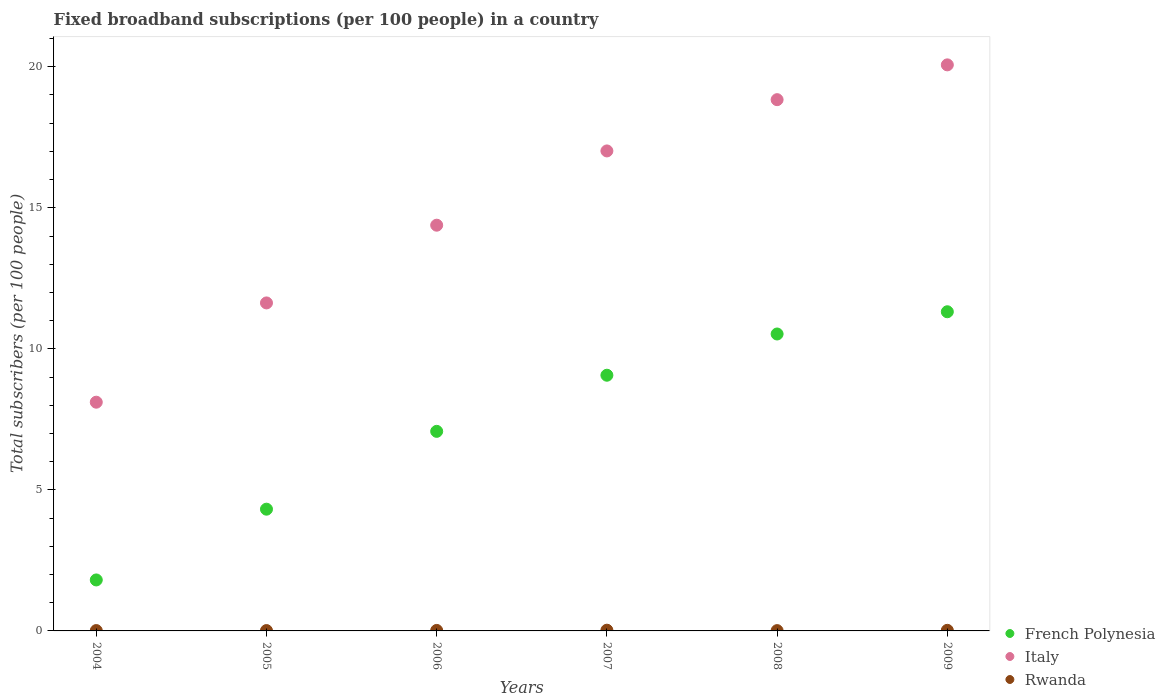How many different coloured dotlines are there?
Your answer should be compact. 3. What is the number of broadband subscriptions in Rwanda in 2008?
Make the answer very short. 0.01. Across all years, what is the maximum number of broadband subscriptions in Rwanda?
Give a very brief answer. 0.03. Across all years, what is the minimum number of broadband subscriptions in Italy?
Offer a very short reply. 8.11. In which year was the number of broadband subscriptions in Rwanda maximum?
Provide a succinct answer. 2007. What is the total number of broadband subscriptions in Rwanda in the graph?
Provide a succinct answer. 0.1. What is the difference between the number of broadband subscriptions in Italy in 2004 and that in 2007?
Your answer should be compact. -8.91. What is the difference between the number of broadband subscriptions in Italy in 2005 and the number of broadband subscriptions in Rwanda in 2009?
Your answer should be very brief. 11.61. What is the average number of broadband subscriptions in French Polynesia per year?
Provide a succinct answer. 7.35. In the year 2004, what is the difference between the number of broadband subscriptions in Rwanda and number of broadband subscriptions in French Polynesia?
Make the answer very short. -1.79. In how many years, is the number of broadband subscriptions in French Polynesia greater than 11?
Provide a short and direct response. 1. What is the ratio of the number of broadband subscriptions in French Polynesia in 2007 to that in 2009?
Offer a very short reply. 0.8. Is the difference between the number of broadband subscriptions in Rwanda in 2007 and 2008 greater than the difference between the number of broadband subscriptions in French Polynesia in 2007 and 2008?
Provide a succinct answer. Yes. What is the difference between the highest and the second highest number of broadband subscriptions in Italy?
Your answer should be very brief. 1.23. What is the difference between the highest and the lowest number of broadband subscriptions in Rwanda?
Make the answer very short. 0.01. In how many years, is the number of broadband subscriptions in French Polynesia greater than the average number of broadband subscriptions in French Polynesia taken over all years?
Ensure brevity in your answer.  3. Is it the case that in every year, the sum of the number of broadband subscriptions in Rwanda and number of broadband subscriptions in French Polynesia  is greater than the number of broadband subscriptions in Italy?
Offer a terse response. No. Does the number of broadband subscriptions in Rwanda monotonically increase over the years?
Give a very brief answer. No. Is the number of broadband subscriptions in French Polynesia strictly less than the number of broadband subscriptions in Italy over the years?
Give a very brief answer. Yes. What is the difference between two consecutive major ticks on the Y-axis?
Give a very brief answer. 5. What is the title of the graph?
Your response must be concise. Fixed broadband subscriptions (per 100 people) in a country. Does "Congo (Democratic)" appear as one of the legend labels in the graph?
Make the answer very short. No. What is the label or title of the Y-axis?
Your response must be concise. Total subscribers (per 100 people). What is the Total subscribers (per 100 people) of French Polynesia in 2004?
Ensure brevity in your answer.  1.81. What is the Total subscribers (per 100 people) of Italy in 2004?
Make the answer very short. 8.11. What is the Total subscribers (per 100 people) in Rwanda in 2004?
Provide a succinct answer. 0.01. What is the Total subscribers (per 100 people) in French Polynesia in 2005?
Make the answer very short. 4.32. What is the Total subscribers (per 100 people) of Italy in 2005?
Offer a very short reply. 11.63. What is the Total subscribers (per 100 people) of Rwanda in 2005?
Keep it short and to the point. 0.01. What is the Total subscribers (per 100 people) of French Polynesia in 2006?
Offer a terse response. 7.07. What is the Total subscribers (per 100 people) of Italy in 2006?
Offer a very short reply. 14.38. What is the Total subscribers (per 100 people) of Rwanda in 2006?
Make the answer very short. 0.02. What is the Total subscribers (per 100 people) of French Polynesia in 2007?
Offer a terse response. 9.06. What is the Total subscribers (per 100 people) of Italy in 2007?
Offer a very short reply. 17.02. What is the Total subscribers (per 100 people) in Rwanda in 2007?
Your answer should be compact. 0.03. What is the Total subscribers (per 100 people) in French Polynesia in 2008?
Offer a very short reply. 10.53. What is the Total subscribers (per 100 people) in Italy in 2008?
Your answer should be very brief. 18.83. What is the Total subscribers (per 100 people) of Rwanda in 2008?
Your response must be concise. 0.01. What is the Total subscribers (per 100 people) of French Polynesia in 2009?
Offer a terse response. 11.31. What is the Total subscribers (per 100 people) in Italy in 2009?
Offer a very short reply. 20.07. What is the Total subscribers (per 100 people) in Rwanda in 2009?
Offer a very short reply. 0.02. Across all years, what is the maximum Total subscribers (per 100 people) in French Polynesia?
Keep it short and to the point. 11.31. Across all years, what is the maximum Total subscribers (per 100 people) of Italy?
Ensure brevity in your answer.  20.07. Across all years, what is the maximum Total subscribers (per 100 people) in Rwanda?
Give a very brief answer. 0.03. Across all years, what is the minimum Total subscribers (per 100 people) of French Polynesia?
Keep it short and to the point. 1.81. Across all years, what is the minimum Total subscribers (per 100 people) of Italy?
Offer a terse response. 8.11. Across all years, what is the minimum Total subscribers (per 100 people) of Rwanda?
Ensure brevity in your answer.  0.01. What is the total Total subscribers (per 100 people) of French Polynesia in the graph?
Provide a succinct answer. 44.1. What is the total Total subscribers (per 100 people) in Italy in the graph?
Offer a terse response. 90.04. What is the total Total subscribers (per 100 people) of Rwanda in the graph?
Give a very brief answer. 0.1. What is the difference between the Total subscribers (per 100 people) in French Polynesia in 2004 and that in 2005?
Keep it short and to the point. -2.51. What is the difference between the Total subscribers (per 100 people) of Italy in 2004 and that in 2005?
Provide a short and direct response. -3.52. What is the difference between the Total subscribers (per 100 people) in Rwanda in 2004 and that in 2005?
Your answer should be very brief. -0. What is the difference between the Total subscribers (per 100 people) of French Polynesia in 2004 and that in 2006?
Your response must be concise. -5.27. What is the difference between the Total subscribers (per 100 people) in Italy in 2004 and that in 2006?
Offer a terse response. -6.28. What is the difference between the Total subscribers (per 100 people) of Rwanda in 2004 and that in 2006?
Offer a terse response. -0.01. What is the difference between the Total subscribers (per 100 people) in French Polynesia in 2004 and that in 2007?
Provide a short and direct response. -7.26. What is the difference between the Total subscribers (per 100 people) in Italy in 2004 and that in 2007?
Your answer should be very brief. -8.91. What is the difference between the Total subscribers (per 100 people) of Rwanda in 2004 and that in 2007?
Keep it short and to the point. -0.01. What is the difference between the Total subscribers (per 100 people) of French Polynesia in 2004 and that in 2008?
Your answer should be compact. -8.72. What is the difference between the Total subscribers (per 100 people) of Italy in 2004 and that in 2008?
Your answer should be compact. -10.72. What is the difference between the Total subscribers (per 100 people) in Rwanda in 2004 and that in 2008?
Offer a very short reply. 0. What is the difference between the Total subscribers (per 100 people) in French Polynesia in 2004 and that in 2009?
Keep it short and to the point. -9.51. What is the difference between the Total subscribers (per 100 people) in Italy in 2004 and that in 2009?
Offer a very short reply. -11.96. What is the difference between the Total subscribers (per 100 people) in Rwanda in 2004 and that in 2009?
Provide a short and direct response. -0.01. What is the difference between the Total subscribers (per 100 people) of French Polynesia in 2005 and that in 2006?
Your answer should be very brief. -2.76. What is the difference between the Total subscribers (per 100 people) of Italy in 2005 and that in 2006?
Keep it short and to the point. -2.76. What is the difference between the Total subscribers (per 100 people) in Rwanda in 2005 and that in 2006?
Provide a short and direct response. -0.01. What is the difference between the Total subscribers (per 100 people) of French Polynesia in 2005 and that in 2007?
Give a very brief answer. -4.75. What is the difference between the Total subscribers (per 100 people) of Italy in 2005 and that in 2007?
Offer a very short reply. -5.39. What is the difference between the Total subscribers (per 100 people) of Rwanda in 2005 and that in 2007?
Give a very brief answer. -0.01. What is the difference between the Total subscribers (per 100 people) in French Polynesia in 2005 and that in 2008?
Your response must be concise. -6.21. What is the difference between the Total subscribers (per 100 people) of Italy in 2005 and that in 2008?
Keep it short and to the point. -7.21. What is the difference between the Total subscribers (per 100 people) in Rwanda in 2005 and that in 2008?
Provide a short and direct response. 0. What is the difference between the Total subscribers (per 100 people) in French Polynesia in 2005 and that in 2009?
Provide a succinct answer. -7. What is the difference between the Total subscribers (per 100 people) of Italy in 2005 and that in 2009?
Give a very brief answer. -8.44. What is the difference between the Total subscribers (per 100 people) of Rwanda in 2005 and that in 2009?
Keep it short and to the point. -0.01. What is the difference between the Total subscribers (per 100 people) of French Polynesia in 2006 and that in 2007?
Your response must be concise. -1.99. What is the difference between the Total subscribers (per 100 people) in Italy in 2006 and that in 2007?
Ensure brevity in your answer.  -2.63. What is the difference between the Total subscribers (per 100 people) in Rwanda in 2006 and that in 2007?
Your response must be concise. -0.01. What is the difference between the Total subscribers (per 100 people) of French Polynesia in 2006 and that in 2008?
Your answer should be very brief. -3.45. What is the difference between the Total subscribers (per 100 people) of Italy in 2006 and that in 2008?
Your answer should be compact. -4.45. What is the difference between the Total subscribers (per 100 people) in Rwanda in 2006 and that in 2008?
Provide a succinct answer. 0.01. What is the difference between the Total subscribers (per 100 people) in French Polynesia in 2006 and that in 2009?
Make the answer very short. -4.24. What is the difference between the Total subscribers (per 100 people) of Italy in 2006 and that in 2009?
Keep it short and to the point. -5.68. What is the difference between the Total subscribers (per 100 people) of Rwanda in 2006 and that in 2009?
Provide a short and direct response. -0. What is the difference between the Total subscribers (per 100 people) of French Polynesia in 2007 and that in 2008?
Your answer should be compact. -1.46. What is the difference between the Total subscribers (per 100 people) of Italy in 2007 and that in 2008?
Keep it short and to the point. -1.82. What is the difference between the Total subscribers (per 100 people) of Rwanda in 2007 and that in 2008?
Your response must be concise. 0.01. What is the difference between the Total subscribers (per 100 people) of French Polynesia in 2007 and that in 2009?
Your response must be concise. -2.25. What is the difference between the Total subscribers (per 100 people) in Italy in 2007 and that in 2009?
Offer a terse response. -3.05. What is the difference between the Total subscribers (per 100 people) in Rwanda in 2007 and that in 2009?
Provide a short and direct response. 0. What is the difference between the Total subscribers (per 100 people) in French Polynesia in 2008 and that in 2009?
Give a very brief answer. -0.79. What is the difference between the Total subscribers (per 100 people) in Italy in 2008 and that in 2009?
Ensure brevity in your answer.  -1.23. What is the difference between the Total subscribers (per 100 people) of Rwanda in 2008 and that in 2009?
Make the answer very short. -0.01. What is the difference between the Total subscribers (per 100 people) of French Polynesia in 2004 and the Total subscribers (per 100 people) of Italy in 2005?
Your response must be concise. -9.82. What is the difference between the Total subscribers (per 100 people) of French Polynesia in 2004 and the Total subscribers (per 100 people) of Rwanda in 2005?
Make the answer very short. 1.79. What is the difference between the Total subscribers (per 100 people) in Italy in 2004 and the Total subscribers (per 100 people) in Rwanda in 2005?
Offer a terse response. 8.1. What is the difference between the Total subscribers (per 100 people) of French Polynesia in 2004 and the Total subscribers (per 100 people) of Italy in 2006?
Give a very brief answer. -12.58. What is the difference between the Total subscribers (per 100 people) in French Polynesia in 2004 and the Total subscribers (per 100 people) in Rwanda in 2006?
Give a very brief answer. 1.79. What is the difference between the Total subscribers (per 100 people) in Italy in 2004 and the Total subscribers (per 100 people) in Rwanda in 2006?
Your response must be concise. 8.09. What is the difference between the Total subscribers (per 100 people) in French Polynesia in 2004 and the Total subscribers (per 100 people) in Italy in 2007?
Offer a terse response. -15.21. What is the difference between the Total subscribers (per 100 people) in French Polynesia in 2004 and the Total subscribers (per 100 people) in Rwanda in 2007?
Provide a succinct answer. 1.78. What is the difference between the Total subscribers (per 100 people) of Italy in 2004 and the Total subscribers (per 100 people) of Rwanda in 2007?
Your response must be concise. 8.08. What is the difference between the Total subscribers (per 100 people) of French Polynesia in 2004 and the Total subscribers (per 100 people) of Italy in 2008?
Make the answer very short. -17.03. What is the difference between the Total subscribers (per 100 people) of French Polynesia in 2004 and the Total subscribers (per 100 people) of Rwanda in 2008?
Give a very brief answer. 1.8. What is the difference between the Total subscribers (per 100 people) of Italy in 2004 and the Total subscribers (per 100 people) of Rwanda in 2008?
Offer a terse response. 8.1. What is the difference between the Total subscribers (per 100 people) of French Polynesia in 2004 and the Total subscribers (per 100 people) of Italy in 2009?
Offer a terse response. -18.26. What is the difference between the Total subscribers (per 100 people) of French Polynesia in 2004 and the Total subscribers (per 100 people) of Rwanda in 2009?
Offer a very short reply. 1.79. What is the difference between the Total subscribers (per 100 people) in Italy in 2004 and the Total subscribers (per 100 people) in Rwanda in 2009?
Your answer should be compact. 8.09. What is the difference between the Total subscribers (per 100 people) of French Polynesia in 2005 and the Total subscribers (per 100 people) of Italy in 2006?
Make the answer very short. -10.07. What is the difference between the Total subscribers (per 100 people) of French Polynesia in 2005 and the Total subscribers (per 100 people) of Rwanda in 2006?
Your answer should be very brief. 4.3. What is the difference between the Total subscribers (per 100 people) of Italy in 2005 and the Total subscribers (per 100 people) of Rwanda in 2006?
Offer a terse response. 11.61. What is the difference between the Total subscribers (per 100 people) in French Polynesia in 2005 and the Total subscribers (per 100 people) in Italy in 2007?
Provide a short and direct response. -12.7. What is the difference between the Total subscribers (per 100 people) in French Polynesia in 2005 and the Total subscribers (per 100 people) in Rwanda in 2007?
Provide a succinct answer. 4.29. What is the difference between the Total subscribers (per 100 people) in Italy in 2005 and the Total subscribers (per 100 people) in Rwanda in 2007?
Ensure brevity in your answer.  11.6. What is the difference between the Total subscribers (per 100 people) of French Polynesia in 2005 and the Total subscribers (per 100 people) of Italy in 2008?
Offer a terse response. -14.52. What is the difference between the Total subscribers (per 100 people) in French Polynesia in 2005 and the Total subscribers (per 100 people) in Rwanda in 2008?
Ensure brevity in your answer.  4.3. What is the difference between the Total subscribers (per 100 people) in Italy in 2005 and the Total subscribers (per 100 people) in Rwanda in 2008?
Your answer should be compact. 11.62. What is the difference between the Total subscribers (per 100 people) in French Polynesia in 2005 and the Total subscribers (per 100 people) in Italy in 2009?
Offer a very short reply. -15.75. What is the difference between the Total subscribers (per 100 people) in French Polynesia in 2005 and the Total subscribers (per 100 people) in Rwanda in 2009?
Provide a short and direct response. 4.29. What is the difference between the Total subscribers (per 100 people) in Italy in 2005 and the Total subscribers (per 100 people) in Rwanda in 2009?
Make the answer very short. 11.61. What is the difference between the Total subscribers (per 100 people) of French Polynesia in 2006 and the Total subscribers (per 100 people) of Italy in 2007?
Your answer should be compact. -9.94. What is the difference between the Total subscribers (per 100 people) in French Polynesia in 2006 and the Total subscribers (per 100 people) in Rwanda in 2007?
Ensure brevity in your answer.  7.05. What is the difference between the Total subscribers (per 100 people) in Italy in 2006 and the Total subscribers (per 100 people) in Rwanda in 2007?
Ensure brevity in your answer.  14.36. What is the difference between the Total subscribers (per 100 people) in French Polynesia in 2006 and the Total subscribers (per 100 people) in Italy in 2008?
Provide a short and direct response. -11.76. What is the difference between the Total subscribers (per 100 people) in French Polynesia in 2006 and the Total subscribers (per 100 people) in Rwanda in 2008?
Your response must be concise. 7.06. What is the difference between the Total subscribers (per 100 people) in Italy in 2006 and the Total subscribers (per 100 people) in Rwanda in 2008?
Give a very brief answer. 14.37. What is the difference between the Total subscribers (per 100 people) in French Polynesia in 2006 and the Total subscribers (per 100 people) in Italy in 2009?
Keep it short and to the point. -12.99. What is the difference between the Total subscribers (per 100 people) of French Polynesia in 2006 and the Total subscribers (per 100 people) of Rwanda in 2009?
Provide a succinct answer. 7.05. What is the difference between the Total subscribers (per 100 people) of Italy in 2006 and the Total subscribers (per 100 people) of Rwanda in 2009?
Offer a very short reply. 14.36. What is the difference between the Total subscribers (per 100 people) of French Polynesia in 2007 and the Total subscribers (per 100 people) of Italy in 2008?
Your answer should be compact. -9.77. What is the difference between the Total subscribers (per 100 people) in French Polynesia in 2007 and the Total subscribers (per 100 people) in Rwanda in 2008?
Keep it short and to the point. 9.05. What is the difference between the Total subscribers (per 100 people) of Italy in 2007 and the Total subscribers (per 100 people) of Rwanda in 2008?
Your response must be concise. 17.01. What is the difference between the Total subscribers (per 100 people) in French Polynesia in 2007 and the Total subscribers (per 100 people) in Italy in 2009?
Provide a succinct answer. -11. What is the difference between the Total subscribers (per 100 people) of French Polynesia in 2007 and the Total subscribers (per 100 people) of Rwanda in 2009?
Provide a succinct answer. 9.04. What is the difference between the Total subscribers (per 100 people) in Italy in 2007 and the Total subscribers (per 100 people) in Rwanda in 2009?
Your answer should be compact. 17. What is the difference between the Total subscribers (per 100 people) of French Polynesia in 2008 and the Total subscribers (per 100 people) of Italy in 2009?
Give a very brief answer. -9.54. What is the difference between the Total subscribers (per 100 people) in French Polynesia in 2008 and the Total subscribers (per 100 people) in Rwanda in 2009?
Offer a terse response. 10.51. What is the difference between the Total subscribers (per 100 people) of Italy in 2008 and the Total subscribers (per 100 people) of Rwanda in 2009?
Provide a short and direct response. 18.81. What is the average Total subscribers (per 100 people) of French Polynesia per year?
Offer a very short reply. 7.35. What is the average Total subscribers (per 100 people) of Italy per year?
Provide a short and direct response. 15.01. What is the average Total subscribers (per 100 people) of Rwanda per year?
Offer a terse response. 0.02. In the year 2004, what is the difference between the Total subscribers (per 100 people) in French Polynesia and Total subscribers (per 100 people) in Italy?
Offer a very short reply. -6.3. In the year 2004, what is the difference between the Total subscribers (per 100 people) of French Polynesia and Total subscribers (per 100 people) of Rwanda?
Your answer should be compact. 1.79. In the year 2004, what is the difference between the Total subscribers (per 100 people) in Italy and Total subscribers (per 100 people) in Rwanda?
Your answer should be very brief. 8.1. In the year 2005, what is the difference between the Total subscribers (per 100 people) of French Polynesia and Total subscribers (per 100 people) of Italy?
Ensure brevity in your answer.  -7.31. In the year 2005, what is the difference between the Total subscribers (per 100 people) of French Polynesia and Total subscribers (per 100 people) of Rwanda?
Keep it short and to the point. 4.3. In the year 2005, what is the difference between the Total subscribers (per 100 people) in Italy and Total subscribers (per 100 people) in Rwanda?
Your answer should be compact. 11.62. In the year 2006, what is the difference between the Total subscribers (per 100 people) of French Polynesia and Total subscribers (per 100 people) of Italy?
Your answer should be very brief. -7.31. In the year 2006, what is the difference between the Total subscribers (per 100 people) of French Polynesia and Total subscribers (per 100 people) of Rwanda?
Your answer should be compact. 7.06. In the year 2006, what is the difference between the Total subscribers (per 100 people) in Italy and Total subscribers (per 100 people) in Rwanda?
Provide a short and direct response. 14.37. In the year 2007, what is the difference between the Total subscribers (per 100 people) in French Polynesia and Total subscribers (per 100 people) in Italy?
Offer a very short reply. -7.95. In the year 2007, what is the difference between the Total subscribers (per 100 people) of French Polynesia and Total subscribers (per 100 people) of Rwanda?
Your response must be concise. 9.04. In the year 2007, what is the difference between the Total subscribers (per 100 people) of Italy and Total subscribers (per 100 people) of Rwanda?
Your answer should be very brief. 16.99. In the year 2008, what is the difference between the Total subscribers (per 100 people) of French Polynesia and Total subscribers (per 100 people) of Italy?
Keep it short and to the point. -8.31. In the year 2008, what is the difference between the Total subscribers (per 100 people) of French Polynesia and Total subscribers (per 100 people) of Rwanda?
Provide a succinct answer. 10.52. In the year 2008, what is the difference between the Total subscribers (per 100 people) in Italy and Total subscribers (per 100 people) in Rwanda?
Your response must be concise. 18.82. In the year 2009, what is the difference between the Total subscribers (per 100 people) in French Polynesia and Total subscribers (per 100 people) in Italy?
Your answer should be very brief. -8.75. In the year 2009, what is the difference between the Total subscribers (per 100 people) in French Polynesia and Total subscribers (per 100 people) in Rwanda?
Keep it short and to the point. 11.29. In the year 2009, what is the difference between the Total subscribers (per 100 people) in Italy and Total subscribers (per 100 people) in Rwanda?
Your response must be concise. 20.05. What is the ratio of the Total subscribers (per 100 people) of French Polynesia in 2004 to that in 2005?
Give a very brief answer. 0.42. What is the ratio of the Total subscribers (per 100 people) of Italy in 2004 to that in 2005?
Provide a succinct answer. 0.7. What is the ratio of the Total subscribers (per 100 people) in French Polynesia in 2004 to that in 2006?
Keep it short and to the point. 0.26. What is the ratio of the Total subscribers (per 100 people) of Italy in 2004 to that in 2006?
Your answer should be compact. 0.56. What is the ratio of the Total subscribers (per 100 people) of Rwanda in 2004 to that in 2006?
Give a very brief answer. 0.7. What is the ratio of the Total subscribers (per 100 people) of French Polynesia in 2004 to that in 2007?
Ensure brevity in your answer.  0.2. What is the ratio of the Total subscribers (per 100 people) in Italy in 2004 to that in 2007?
Your answer should be compact. 0.48. What is the ratio of the Total subscribers (per 100 people) of Rwanda in 2004 to that in 2007?
Ensure brevity in your answer.  0.48. What is the ratio of the Total subscribers (per 100 people) in French Polynesia in 2004 to that in 2008?
Offer a very short reply. 0.17. What is the ratio of the Total subscribers (per 100 people) of Italy in 2004 to that in 2008?
Offer a very short reply. 0.43. What is the ratio of the Total subscribers (per 100 people) of Rwanda in 2004 to that in 2008?
Give a very brief answer. 1.13. What is the ratio of the Total subscribers (per 100 people) in French Polynesia in 2004 to that in 2009?
Keep it short and to the point. 0.16. What is the ratio of the Total subscribers (per 100 people) of Italy in 2004 to that in 2009?
Provide a succinct answer. 0.4. What is the ratio of the Total subscribers (per 100 people) in Rwanda in 2004 to that in 2009?
Make the answer very short. 0.59. What is the ratio of the Total subscribers (per 100 people) of French Polynesia in 2005 to that in 2006?
Provide a short and direct response. 0.61. What is the ratio of the Total subscribers (per 100 people) in Italy in 2005 to that in 2006?
Give a very brief answer. 0.81. What is the ratio of the Total subscribers (per 100 people) in Rwanda in 2005 to that in 2006?
Ensure brevity in your answer.  0.71. What is the ratio of the Total subscribers (per 100 people) of French Polynesia in 2005 to that in 2007?
Offer a terse response. 0.48. What is the ratio of the Total subscribers (per 100 people) of Italy in 2005 to that in 2007?
Keep it short and to the point. 0.68. What is the ratio of the Total subscribers (per 100 people) of Rwanda in 2005 to that in 2007?
Ensure brevity in your answer.  0.49. What is the ratio of the Total subscribers (per 100 people) in French Polynesia in 2005 to that in 2008?
Your response must be concise. 0.41. What is the ratio of the Total subscribers (per 100 people) of Italy in 2005 to that in 2008?
Ensure brevity in your answer.  0.62. What is the ratio of the Total subscribers (per 100 people) of Rwanda in 2005 to that in 2008?
Offer a very short reply. 1.14. What is the ratio of the Total subscribers (per 100 people) of French Polynesia in 2005 to that in 2009?
Ensure brevity in your answer.  0.38. What is the ratio of the Total subscribers (per 100 people) in Italy in 2005 to that in 2009?
Give a very brief answer. 0.58. What is the ratio of the Total subscribers (per 100 people) of Rwanda in 2005 to that in 2009?
Your answer should be very brief. 0.6. What is the ratio of the Total subscribers (per 100 people) in French Polynesia in 2006 to that in 2007?
Provide a short and direct response. 0.78. What is the ratio of the Total subscribers (per 100 people) in Italy in 2006 to that in 2007?
Give a very brief answer. 0.85. What is the ratio of the Total subscribers (per 100 people) of Rwanda in 2006 to that in 2007?
Keep it short and to the point. 0.69. What is the ratio of the Total subscribers (per 100 people) in French Polynesia in 2006 to that in 2008?
Provide a short and direct response. 0.67. What is the ratio of the Total subscribers (per 100 people) in Italy in 2006 to that in 2008?
Provide a short and direct response. 0.76. What is the ratio of the Total subscribers (per 100 people) in Rwanda in 2006 to that in 2008?
Provide a succinct answer. 1.61. What is the ratio of the Total subscribers (per 100 people) of French Polynesia in 2006 to that in 2009?
Keep it short and to the point. 0.63. What is the ratio of the Total subscribers (per 100 people) of Italy in 2006 to that in 2009?
Offer a very short reply. 0.72. What is the ratio of the Total subscribers (per 100 people) of Rwanda in 2006 to that in 2009?
Keep it short and to the point. 0.84. What is the ratio of the Total subscribers (per 100 people) in French Polynesia in 2007 to that in 2008?
Make the answer very short. 0.86. What is the ratio of the Total subscribers (per 100 people) of Italy in 2007 to that in 2008?
Provide a short and direct response. 0.9. What is the ratio of the Total subscribers (per 100 people) of Rwanda in 2007 to that in 2008?
Provide a short and direct response. 2.34. What is the ratio of the Total subscribers (per 100 people) of French Polynesia in 2007 to that in 2009?
Your answer should be compact. 0.8. What is the ratio of the Total subscribers (per 100 people) in Italy in 2007 to that in 2009?
Your answer should be compact. 0.85. What is the ratio of the Total subscribers (per 100 people) of Rwanda in 2007 to that in 2009?
Keep it short and to the point. 1.22. What is the ratio of the Total subscribers (per 100 people) of French Polynesia in 2008 to that in 2009?
Give a very brief answer. 0.93. What is the ratio of the Total subscribers (per 100 people) in Italy in 2008 to that in 2009?
Give a very brief answer. 0.94. What is the ratio of the Total subscribers (per 100 people) in Rwanda in 2008 to that in 2009?
Offer a very short reply. 0.52. What is the difference between the highest and the second highest Total subscribers (per 100 people) in French Polynesia?
Provide a succinct answer. 0.79. What is the difference between the highest and the second highest Total subscribers (per 100 people) of Italy?
Keep it short and to the point. 1.23. What is the difference between the highest and the second highest Total subscribers (per 100 people) of Rwanda?
Keep it short and to the point. 0. What is the difference between the highest and the lowest Total subscribers (per 100 people) of French Polynesia?
Offer a terse response. 9.51. What is the difference between the highest and the lowest Total subscribers (per 100 people) of Italy?
Your answer should be compact. 11.96. What is the difference between the highest and the lowest Total subscribers (per 100 people) of Rwanda?
Ensure brevity in your answer.  0.01. 